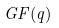<formula> <loc_0><loc_0><loc_500><loc_500>G F ( q )</formula> 